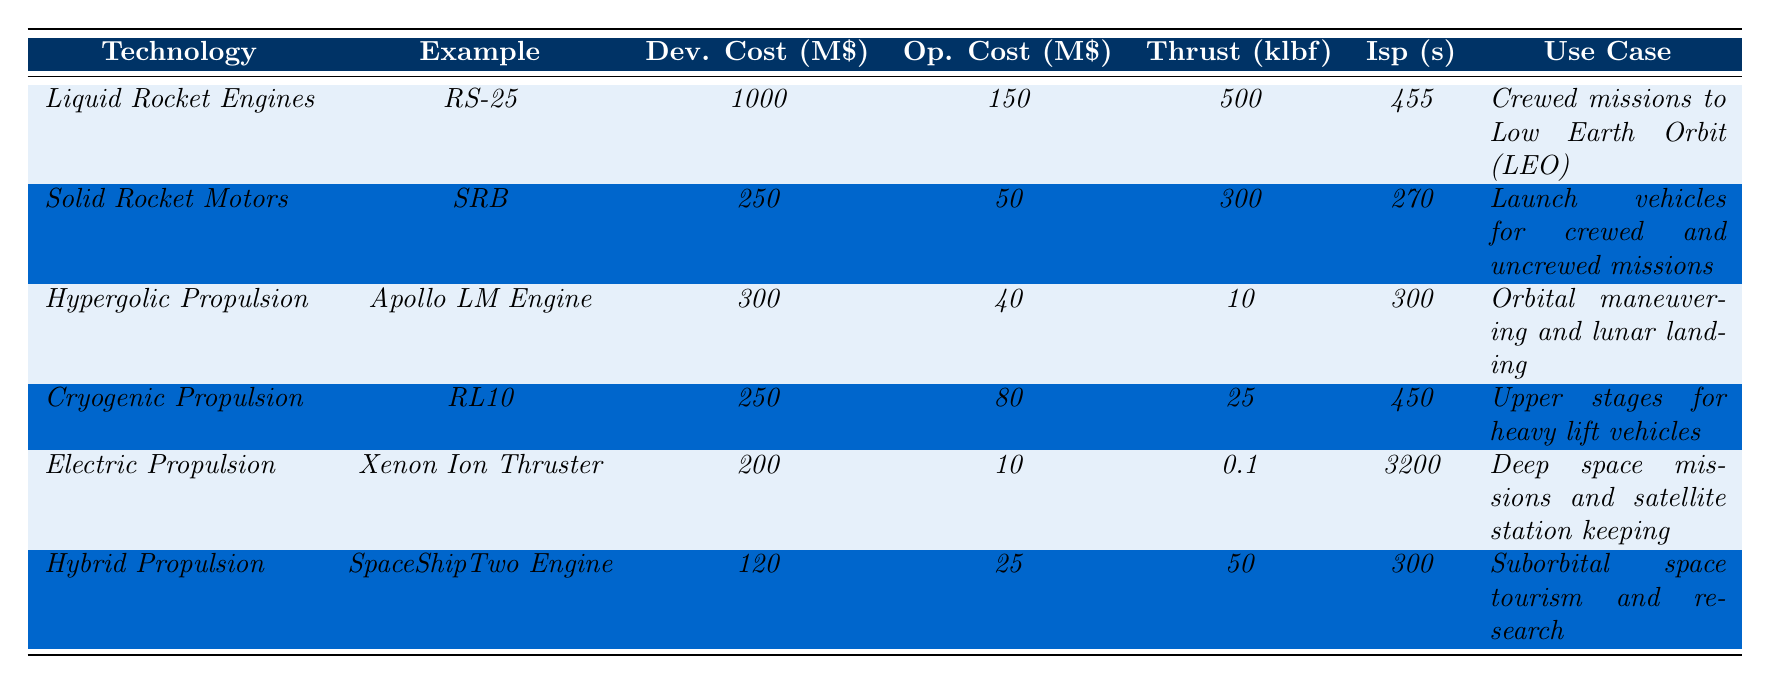What is the development cost of Liquid Rocket Engines? The table shows that the development cost of Liquid Rocket Engines is listed under the column "Dev. Cost (M\$)" as $1000 million.
Answer: 1000 million USD Which propulsion technology has the lowest operational cost per flight? By looking at the "Op. Cost (M\$)" column, Electric Propulsion has the lowest operational cost at $10 million per flight, compared to other technologies.
Answer: Electric Propulsion What is the total thrust of all the propulsion technologies combined? To get the total thrust, we add the values in the "Thrust (klbf)" column: 500 + 300 + 10 + 25 + 0.1 + 50 = 885.1 klbf.
Answer: 885.1 klbf Is the specific impulse of Electric Propulsion higher than that of Solid Rocket Motors? Electric Propulsion has a specific impulse of 3200 seconds, while Solid Rocket Motors have a specific impulse of 270 seconds. Since 3200 > 270, the statement is true.
Answer: Yes Which propulsion technology offers the best specific impulse and what is its value? The "Isp (s)" column indicates that Electric Propulsion has the highest specific impulse at 3200 seconds, compared to other technologies.
Answer: 3200 seconds What is the difference in development cost between Liquid Rocket Engines and Hybrid Propulsion? The development cost for Liquid Rocket Engines is $1000 million, and for Hybrid Propulsion, it is $120 million. The difference is calculated as 1000 - 120 = 880 million USD.
Answer: 880 million USD Which propulsion technologies are suited for crewed missions? From the "Use Case" column, both Liquid Rocket Engines and Solid Rocket Motors are indicated as suitable for crewed missions.
Answer: Liquid Rocket Engines and Solid Rocket Motors What is the average operational cost of Hypergolic Propulsion and Cryogenic Propulsion? The operational costs for Hypergolic Propulsion and Cryogenic Propulsion are $40 million and $80 million, respectively. The average is calculated as (40 + 80) / 2 = 60 million USD.
Answer: 60 million USD Which propulsion technology provides thrust greater than 300 klbf but has a specific impulse of less than 400 seconds? Referring to the "Thrust (klbf)" and "Isp (s)" columns, Solid Rocket Motors have a thrust of 300 klbf and a specific impulse of 270 seconds, which meets the criteria.
Answer: Solid Rocket Motors What is the use case for Cryogenic Propulsion? Looking at the "Use Case" column, Cryogenic Propulsion is described as being used for upper stages of heavy lift vehicles.
Answer: Upper stages for heavy lift vehicles Which propulsion technology has a greater thrust-to-cost ratio (using development costs)? Thrust-to-cost ratios can be calculated by dividing thrust by development cost: Liquid Rocket Engines (500/1000), Solid Rocket Motors (300/250), etc. Solid Rocket Motors yield the highest ratio at 1.2 klbf/million USD.
Answer: Solid Rocket Motors 